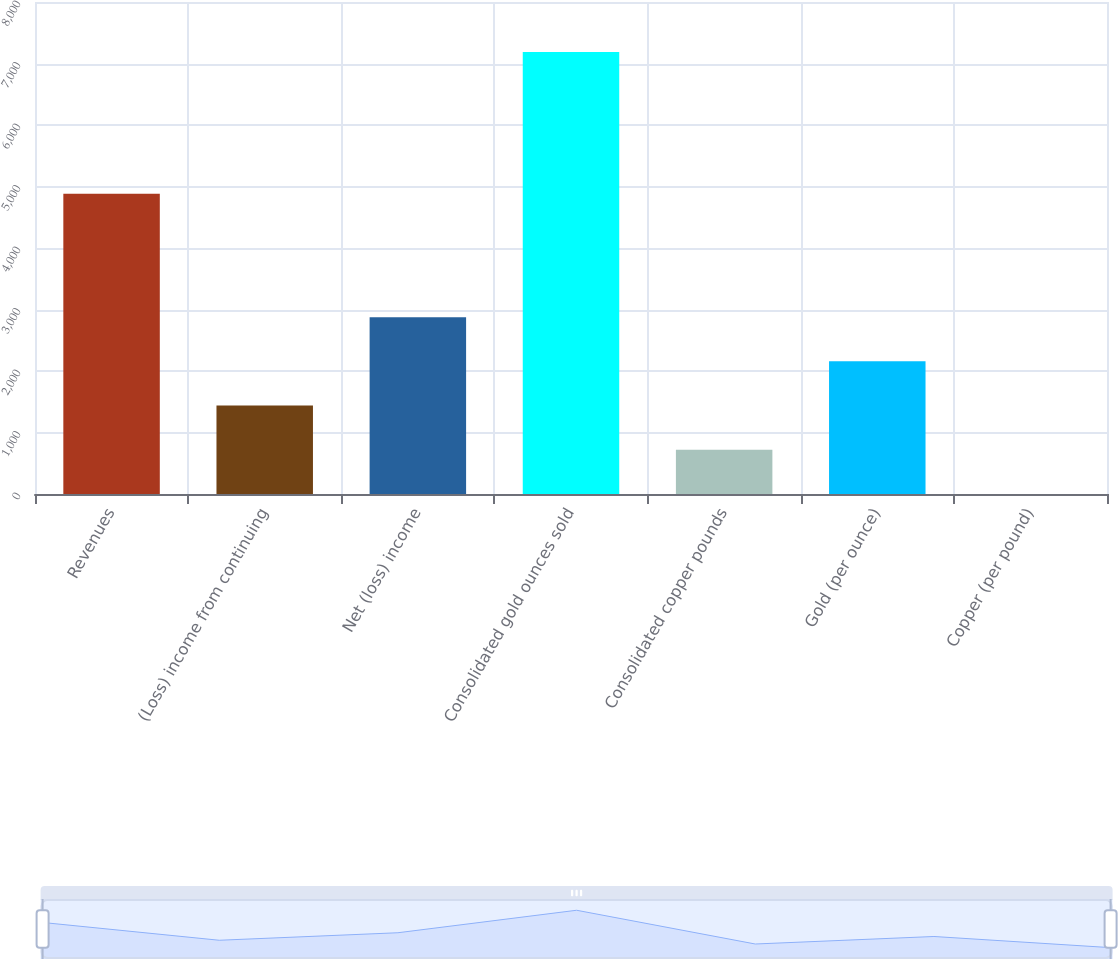<chart> <loc_0><loc_0><loc_500><loc_500><bar_chart><fcel>Revenues<fcel>(Loss) income from continuing<fcel>Net (loss) income<fcel>Consolidated gold ounces sold<fcel>Consolidated copper pounds<fcel>Gold (per ounce)<fcel>Copper (per pound)<nl><fcel>4882<fcel>1438.44<fcel>2875.34<fcel>7186<fcel>719.99<fcel>2156.89<fcel>1.54<nl></chart> 